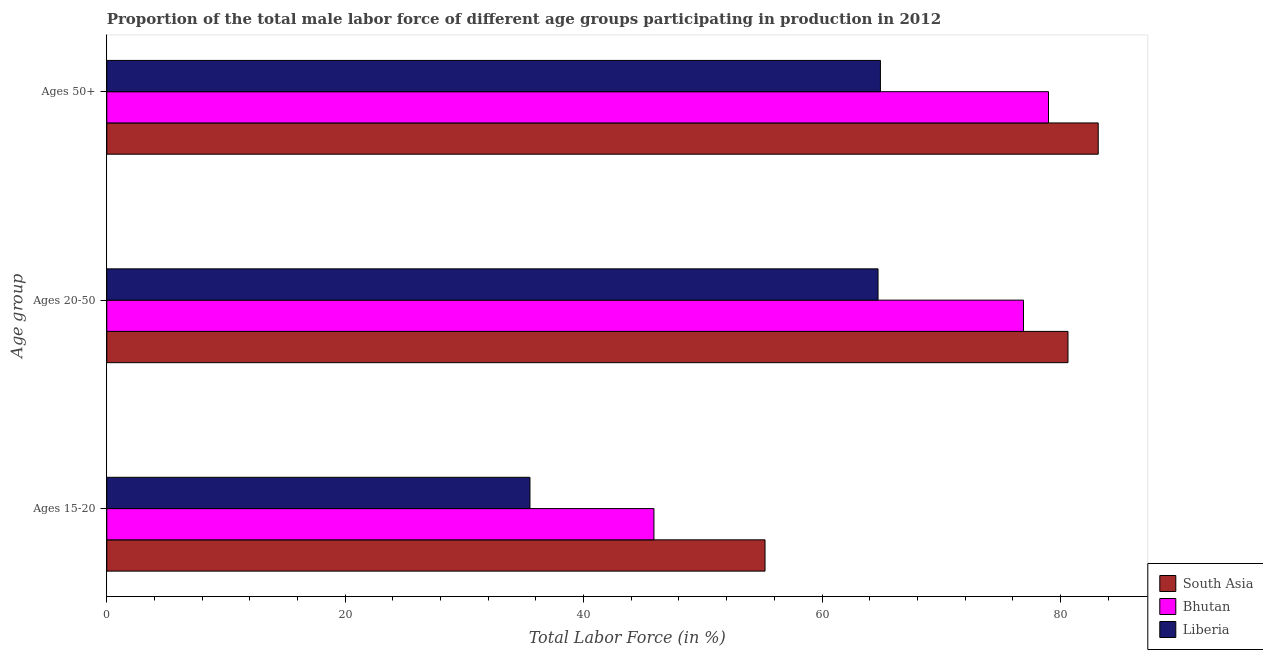How many different coloured bars are there?
Provide a succinct answer. 3. How many groups of bars are there?
Make the answer very short. 3. How many bars are there on the 2nd tick from the top?
Provide a succinct answer. 3. How many bars are there on the 3rd tick from the bottom?
Give a very brief answer. 3. What is the label of the 3rd group of bars from the top?
Offer a terse response. Ages 15-20. What is the percentage of male labor force within the age group 15-20 in Liberia?
Your answer should be compact. 35.5. Across all countries, what is the maximum percentage of male labor force above age 50?
Your response must be concise. 83.17. Across all countries, what is the minimum percentage of male labor force within the age group 15-20?
Ensure brevity in your answer.  35.5. In which country was the percentage of male labor force within the age group 15-20 maximum?
Make the answer very short. South Asia. In which country was the percentage of male labor force above age 50 minimum?
Offer a very short reply. Liberia. What is the total percentage of male labor force within the age group 20-50 in the graph?
Offer a very short reply. 222.24. What is the difference between the percentage of male labor force within the age group 20-50 in Liberia and that in Bhutan?
Your response must be concise. -12.2. What is the difference between the percentage of male labor force above age 50 in Bhutan and the percentage of male labor force within the age group 20-50 in Liberia?
Provide a succinct answer. 14.3. What is the average percentage of male labor force within the age group 20-50 per country?
Your answer should be very brief. 74.08. What is the difference between the percentage of male labor force above age 50 and percentage of male labor force within the age group 20-50 in South Asia?
Ensure brevity in your answer.  2.54. What is the ratio of the percentage of male labor force within the age group 15-20 in South Asia to that in Liberia?
Your answer should be compact. 1.56. What is the difference between the highest and the second highest percentage of male labor force within the age group 15-20?
Give a very brief answer. 9.32. What is the difference between the highest and the lowest percentage of male labor force above age 50?
Your answer should be very brief. 18.27. Is the sum of the percentage of male labor force within the age group 20-50 in South Asia and Liberia greater than the maximum percentage of male labor force within the age group 15-20 across all countries?
Give a very brief answer. Yes. What does the 2nd bar from the top in Ages 50+ represents?
Your answer should be very brief. Bhutan. What does the 3rd bar from the bottom in Ages 20-50 represents?
Keep it short and to the point. Liberia. How many countries are there in the graph?
Keep it short and to the point. 3. What is the difference between two consecutive major ticks on the X-axis?
Your answer should be very brief. 20. Are the values on the major ticks of X-axis written in scientific E-notation?
Give a very brief answer. No. Does the graph contain grids?
Your answer should be compact. No. What is the title of the graph?
Ensure brevity in your answer.  Proportion of the total male labor force of different age groups participating in production in 2012. What is the label or title of the X-axis?
Your response must be concise. Total Labor Force (in %). What is the label or title of the Y-axis?
Offer a very short reply. Age group. What is the Total Labor Force (in %) in South Asia in Ages 15-20?
Make the answer very short. 55.22. What is the Total Labor Force (in %) of Bhutan in Ages 15-20?
Keep it short and to the point. 45.9. What is the Total Labor Force (in %) in Liberia in Ages 15-20?
Your response must be concise. 35.5. What is the Total Labor Force (in %) of South Asia in Ages 20-50?
Provide a succinct answer. 80.64. What is the Total Labor Force (in %) of Bhutan in Ages 20-50?
Your answer should be very brief. 76.9. What is the Total Labor Force (in %) in Liberia in Ages 20-50?
Provide a short and direct response. 64.7. What is the Total Labor Force (in %) in South Asia in Ages 50+?
Ensure brevity in your answer.  83.17. What is the Total Labor Force (in %) of Bhutan in Ages 50+?
Your answer should be very brief. 79. What is the Total Labor Force (in %) of Liberia in Ages 50+?
Your answer should be very brief. 64.9. Across all Age group, what is the maximum Total Labor Force (in %) in South Asia?
Keep it short and to the point. 83.17. Across all Age group, what is the maximum Total Labor Force (in %) of Bhutan?
Offer a very short reply. 79. Across all Age group, what is the maximum Total Labor Force (in %) of Liberia?
Make the answer very short. 64.9. Across all Age group, what is the minimum Total Labor Force (in %) of South Asia?
Provide a short and direct response. 55.22. Across all Age group, what is the minimum Total Labor Force (in %) of Bhutan?
Provide a succinct answer. 45.9. Across all Age group, what is the minimum Total Labor Force (in %) of Liberia?
Provide a short and direct response. 35.5. What is the total Total Labor Force (in %) in South Asia in the graph?
Your answer should be compact. 219.03. What is the total Total Labor Force (in %) in Bhutan in the graph?
Offer a terse response. 201.8. What is the total Total Labor Force (in %) of Liberia in the graph?
Ensure brevity in your answer.  165.1. What is the difference between the Total Labor Force (in %) in South Asia in Ages 15-20 and that in Ages 20-50?
Your response must be concise. -25.41. What is the difference between the Total Labor Force (in %) of Bhutan in Ages 15-20 and that in Ages 20-50?
Your answer should be compact. -31. What is the difference between the Total Labor Force (in %) of Liberia in Ages 15-20 and that in Ages 20-50?
Give a very brief answer. -29.2. What is the difference between the Total Labor Force (in %) in South Asia in Ages 15-20 and that in Ages 50+?
Offer a very short reply. -27.95. What is the difference between the Total Labor Force (in %) in Bhutan in Ages 15-20 and that in Ages 50+?
Ensure brevity in your answer.  -33.1. What is the difference between the Total Labor Force (in %) of Liberia in Ages 15-20 and that in Ages 50+?
Provide a succinct answer. -29.4. What is the difference between the Total Labor Force (in %) of South Asia in Ages 20-50 and that in Ages 50+?
Your answer should be compact. -2.54. What is the difference between the Total Labor Force (in %) in Bhutan in Ages 20-50 and that in Ages 50+?
Provide a short and direct response. -2.1. What is the difference between the Total Labor Force (in %) in Liberia in Ages 20-50 and that in Ages 50+?
Your response must be concise. -0.2. What is the difference between the Total Labor Force (in %) in South Asia in Ages 15-20 and the Total Labor Force (in %) in Bhutan in Ages 20-50?
Offer a very short reply. -21.68. What is the difference between the Total Labor Force (in %) of South Asia in Ages 15-20 and the Total Labor Force (in %) of Liberia in Ages 20-50?
Provide a short and direct response. -9.48. What is the difference between the Total Labor Force (in %) of Bhutan in Ages 15-20 and the Total Labor Force (in %) of Liberia in Ages 20-50?
Ensure brevity in your answer.  -18.8. What is the difference between the Total Labor Force (in %) of South Asia in Ages 15-20 and the Total Labor Force (in %) of Bhutan in Ages 50+?
Keep it short and to the point. -23.78. What is the difference between the Total Labor Force (in %) of South Asia in Ages 15-20 and the Total Labor Force (in %) of Liberia in Ages 50+?
Your response must be concise. -9.68. What is the difference between the Total Labor Force (in %) in Bhutan in Ages 15-20 and the Total Labor Force (in %) in Liberia in Ages 50+?
Provide a short and direct response. -19. What is the difference between the Total Labor Force (in %) in South Asia in Ages 20-50 and the Total Labor Force (in %) in Bhutan in Ages 50+?
Provide a succinct answer. 1.64. What is the difference between the Total Labor Force (in %) in South Asia in Ages 20-50 and the Total Labor Force (in %) in Liberia in Ages 50+?
Keep it short and to the point. 15.73. What is the difference between the Total Labor Force (in %) in Bhutan in Ages 20-50 and the Total Labor Force (in %) in Liberia in Ages 50+?
Ensure brevity in your answer.  12. What is the average Total Labor Force (in %) in South Asia per Age group?
Make the answer very short. 73.01. What is the average Total Labor Force (in %) in Bhutan per Age group?
Keep it short and to the point. 67.27. What is the average Total Labor Force (in %) of Liberia per Age group?
Provide a succinct answer. 55.03. What is the difference between the Total Labor Force (in %) in South Asia and Total Labor Force (in %) in Bhutan in Ages 15-20?
Offer a very short reply. 9.32. What is the difference between the Total Labor Force (in %) in South Asia and Total Labor Force (in %) in Liberia in Ages 15-20?
Provide a short and direct response. 19.72. What is the difference between the Total Labor Force (in %) of Bhutan and Total Labor Force (in %) of Liberia in Ages 15-20?
Offer a terse response. 10.4. What is the difference between the Total Labor Force (in %) of South Asia and Total Labor Force (in %) of Bhutan in Ages 20-50?
Provide a succinct answer. 3.73. What is the difference between the Total Labor Force (in %) in South Asia and Total Labor Force (in %) in Liberia in Ages 20-50?
Your answer should be compact. 15.94. What is the difference between the Total Labor Force (in %) of Bhutan and Total Labor Force (in %) of Liberia in Ages 20-50?
Give a very brief answer. 12.2. What is the difference between the Total Labor Force (in %) of South Asia and Total Labor Force (in %) of Bhutan in Ages 50+?
Your response must be concise. 4.17. What is the difference between the Total Labor Force (in %) in South Asia and Total Labor Force (in %) in Liberia in Ages 50+?
Provide a succinct answer. 18.27. What is the difference between the Total Labor Force (in %) in Bhutan and Total Labor Force (in %) in Liberia in Ages 50+?
Give a very brief answer. 14.1. What is the ratio of the Total Labor Force (in %) in South Asia in Ages 15-20 to that in Ages 20-50?
Provide a succinct answer. 0.68. What is the ratio of the Total Labor Force (in %) of Bhutan in Ages 15-20 to that in Ages 20-50?
Your answer should be very brief. 0.6. What is the ratio of the Total Labor Force (in %) of Liberia in Ages 15-20 to that in Ages 20-50?
Your answer should be compact. 0.55. What is the ratio of the Total Labor Force (in %) of South Asia in Ages 15-20 to that in Ages 50+?
Your response must be concise. 0.66. What is the ratio of the Total Labor Force (in %) of Bhutan in Ages 15-20 to that in Ages 50+?
Your answer should be very brief. 0.58. What is the ratio of the Total Labor Force (in %) in Liberia in Ages 15-20 to that in Ages 50+?
Provide a succinct answer. 0.55. What is the ratio of the Total Labor Force (in %) of South Asia in Ages 20-50 to that in Ages 50+?
Ensure brevity in your answer.  0.97. What is the ratio of the Total Labor Force (in %) of Bhutan in Ages 20-50 to that in Ages 50+?
Your response must be concise. 0.97. What is the difference between the highest and the second highest Total Labor Force (in %) in South Asia?
Your answer should be compact. 2.54. What is the difference between the highest and the lowest Total Labor Force (in %) in South Asia?
Provide a succinct answer. 27.95. What is the difference between the highest and the lowest Total Labor Force (in %) of Bhutan?
Your answer should be very brief. 33.1. What is the difference between the highest and the lowest Total Labor Force (in %) of Liberia?
Provide a succinct answer. 29.4. 